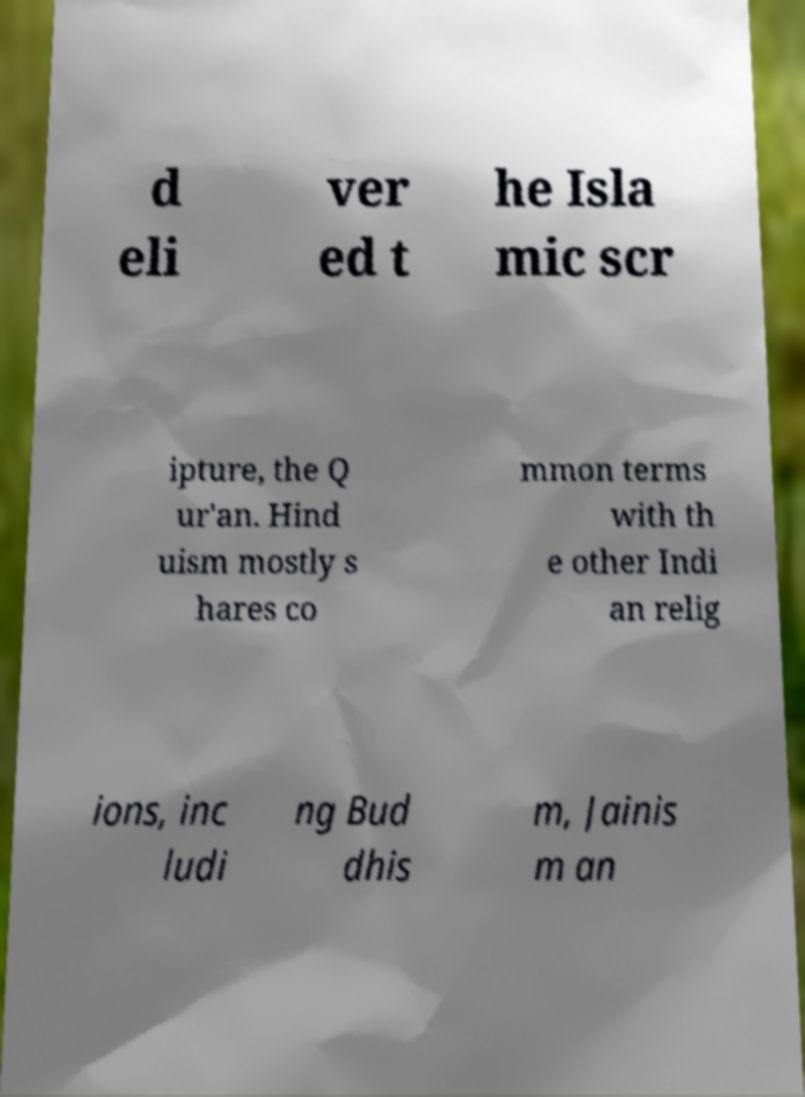For documentation purposes, I need the text within this image transcribed. Could you provide that? d eli ver ed t he Isla mic scr ipture, the Q ur'an. Hind uism mostly s hares co mmon terms with th e other Indi an relig ions, inc ludi ng Bud dhis m, Jainis m an 